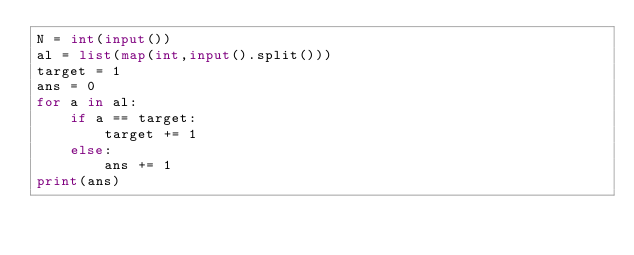<code> <loc_0><loc_0><loc_500><loc_500><_Python_>N = int(input())
al = list(map(int,input().split()))
target = 1
ans = 0
for a in al:
    if a == target:
        target += 1
    else:
        ans += 1
print(ans)</code> 